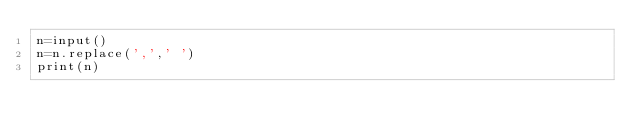Convert code to text. <code><loc_0><loc_0><loc_500><loc_500><_Python_>n=input()
n=n.replace(',',' ')
print(n)</code> 